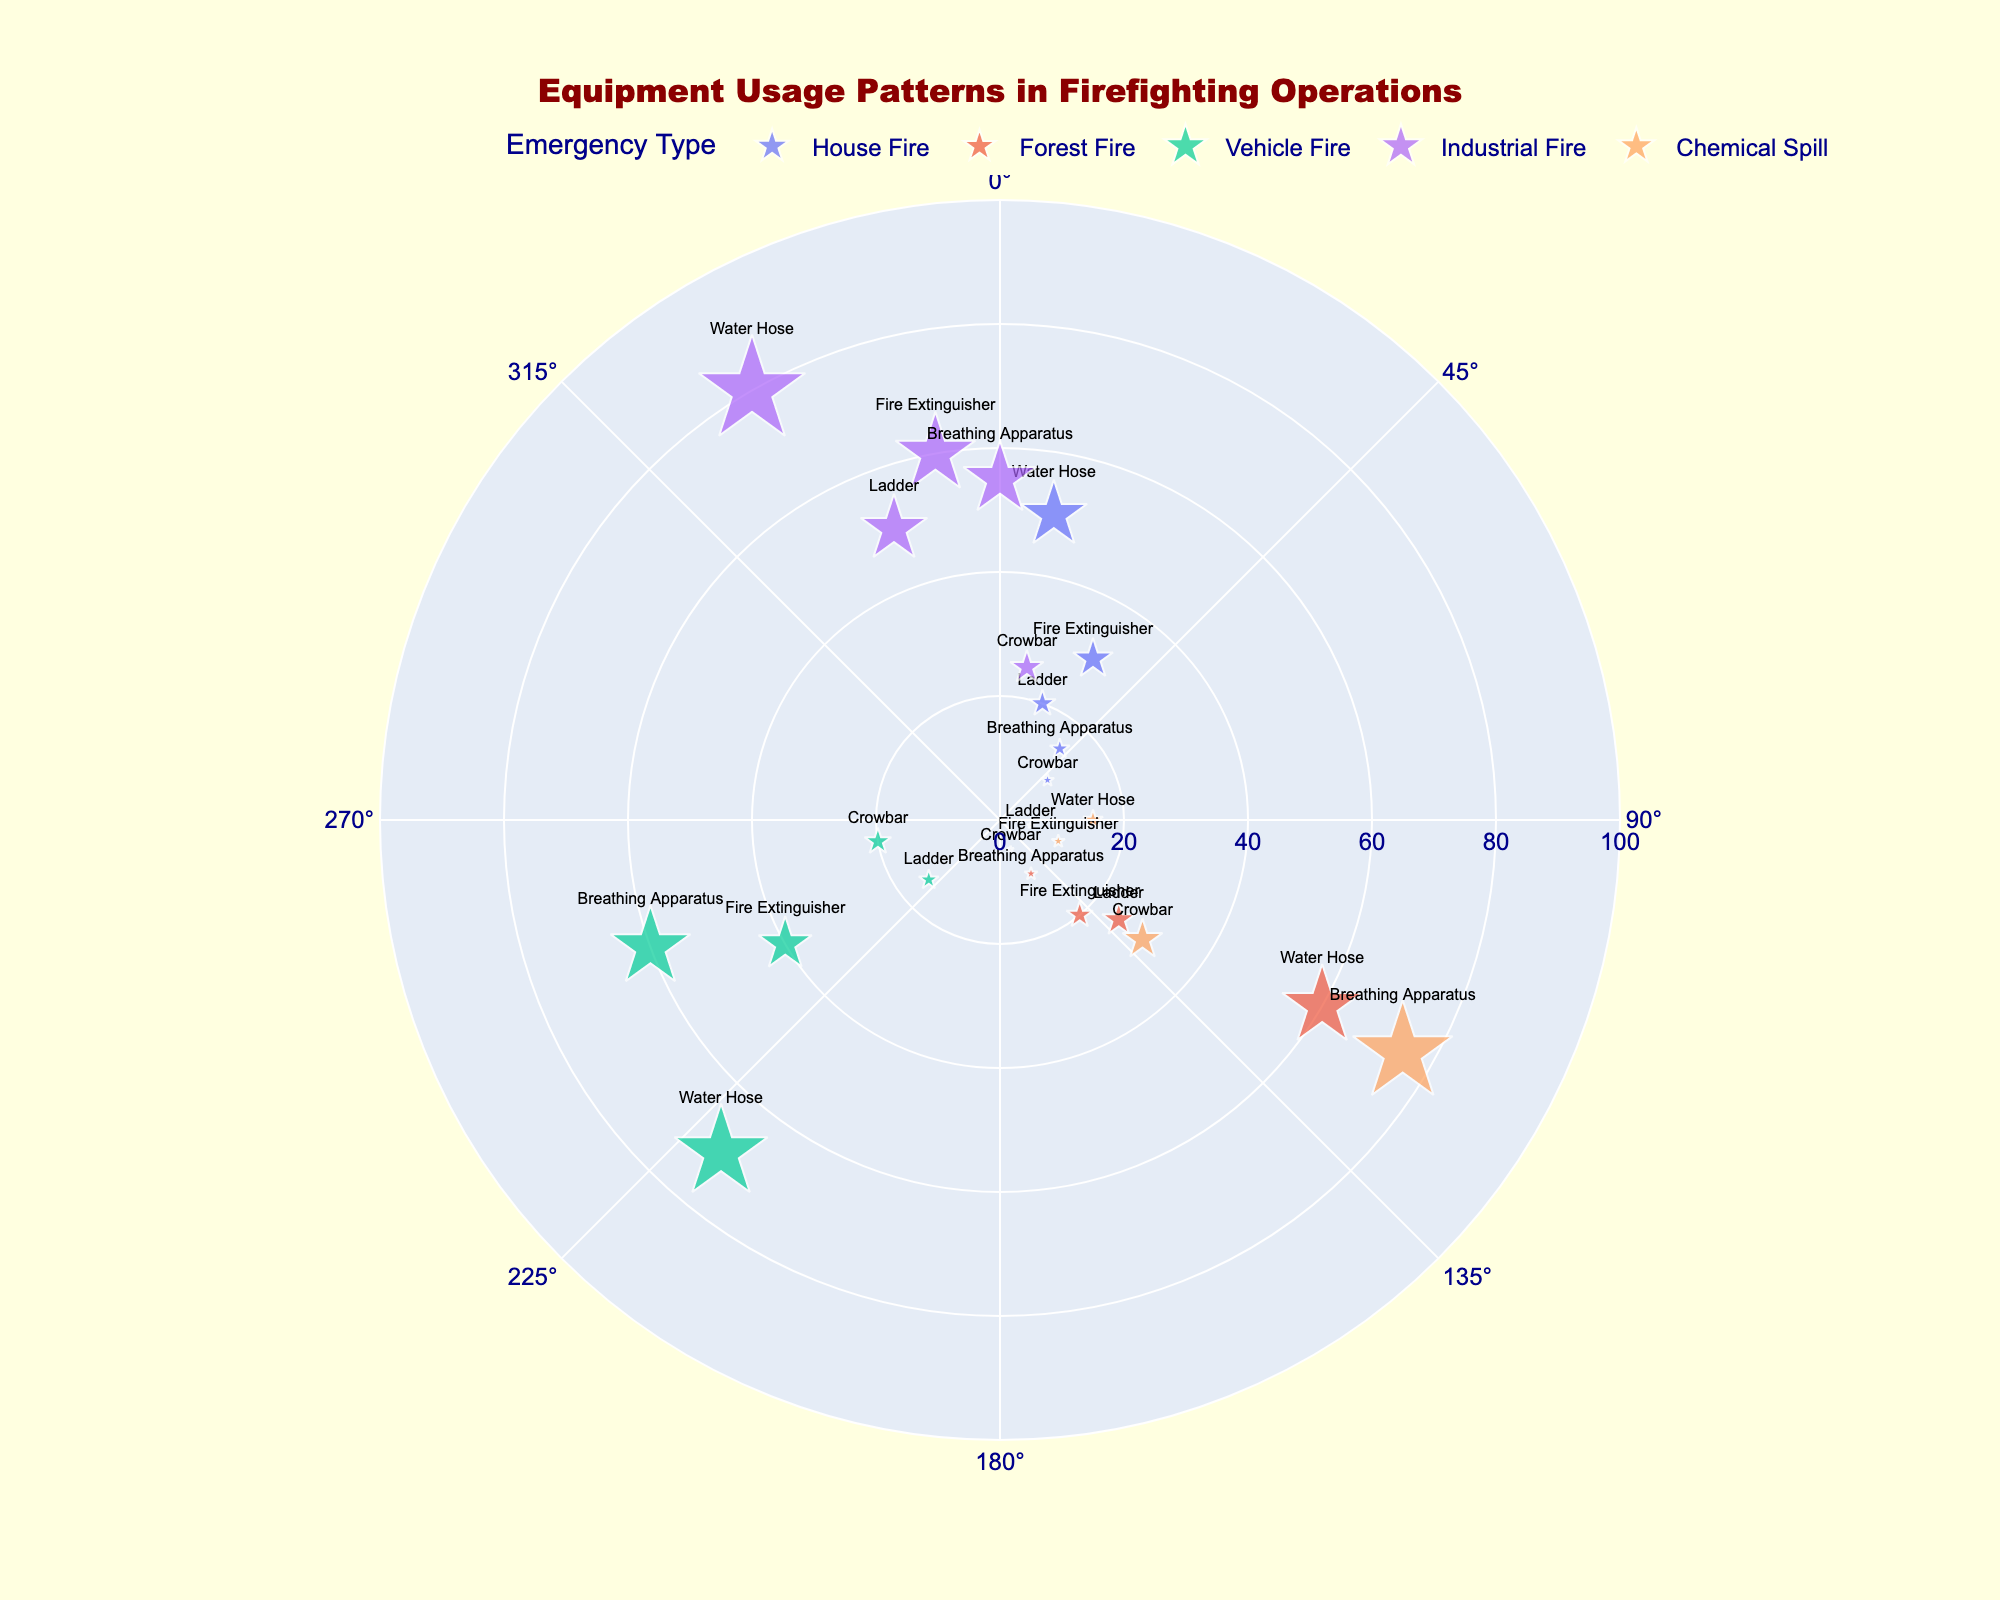What is the title of the figure? The title of the figure is typically located at the top and is usually in larger, bold font compared to the rest of the text in the chart. The position, style, and content make the title easily identifiable.
Answer: Equipment Usage Patterns in Firefighting Operations Which emergency type uses the Water Hose most frequently? Look for the data points with "Water Hose" as the equipment type, then identify the emergency type with the highest frequency value for this equipment.
Answer: Industrial Fire How frequently is the Crowbar used in House Fires and Vehicle Fires combined? Locate the data points for House Fire with Crowbar (10) and Vehicle Fire with Crowbar (20), then sum these two frequency values.
Answer: 30 Which emergency type uses the Breathing Apparatus most frequently, and what is the frequency? Find the data points with "Breathing Apparatus" as the equipment type, then compare the frequency values to identify the maximum and note the corresponding emergency type.
Answer: Chemical Spill, 75 Is there more usage of Fire Extinguishers in House Fires or Vehicle Fires? Compare the frequency values for Fire Extinguishers in House Fires (30) and Vehicle Fires (40).
Answer: Vehicle Fires What's the average frequency of equipment use in Forest Fires? Identify the frequency values for all equipment types in Forest Fires (60, 25, 20, 10, 5), sum them up (60 + 25 + 20 + 10 + 5 = 120), and then divide by the number of equipment types (5).
Answer: 24 Between House Fires and Forest Fires, which has a higher average frequency of equipment use? Calculate the average frequency for House Fires (50, 20, 30, 15, 10: 50 + 20 + 30 + 15 + 10 = 125/5 = 25) and for Forest Fires (60, 25, 20, 10, 5: 60 + 25 + 20 + 10 + 5 = 120/5 = 24), then compare the two averages.
Answer: House Fires What is the least frequently used equipment in Chemical Spills? Locate the data points under "Chemical Spill" and identify the minimum frequency among them (Water Hose 15, Ladder 5, Fire Extinguisher 10, Breathing Apparatus 75, Crowbar 30).
Answer: Ladder, 5 For which emergency type is the frequency value of Fire Extinguisher closest to 30? Locate the Fire Extinguisher frequency values (House Fire 30, Forest Fire 20, Vehicle Fire 40, Industrial Fire 60, Chemical Spill 10), then identify which value is closest to 30.
Answer: House Fire What is the most frequently used equipment in Industrial Fires, and how many times is it used? Identify all equipment types for Industrial Fires (Water Hose 80, Ladder 50, Fire Extinguisher 60, Breathing Apparatus 55, Crowbar 25) and find the one with the highest frequency.
Answer: Water Hose, 80 